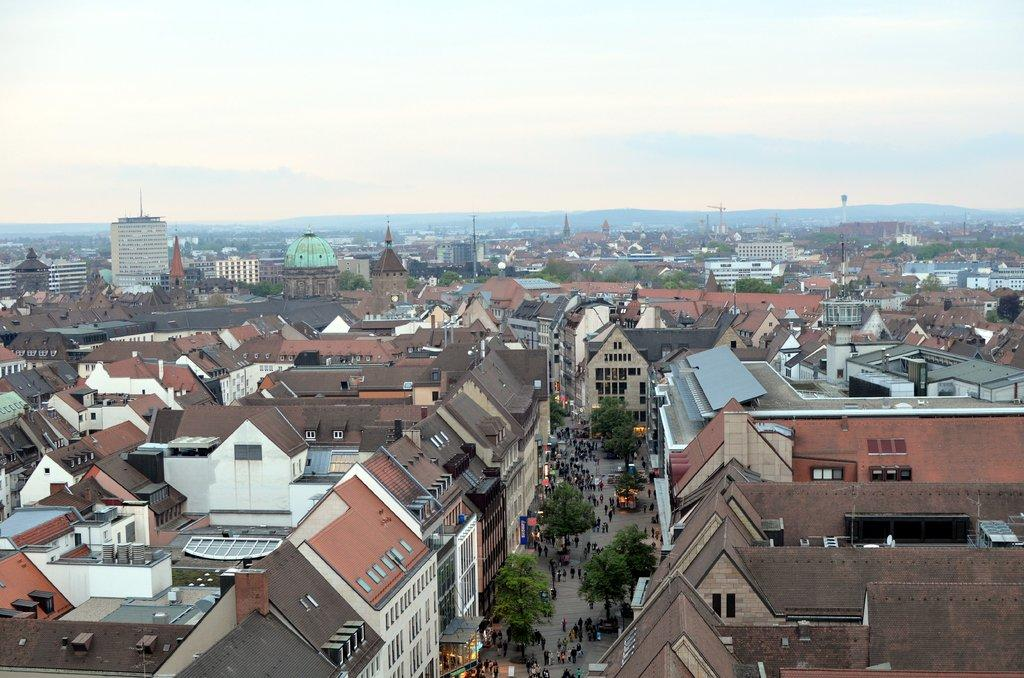What type of structures can be seen in the image? There are buildings and towers in the image. What else is present in the image besides structures? There are trees and people walking in the image. How would you describe the sky in the image? The sky is cloudy in the image. What type of jewel can be seen on the tower in the image? There is no jewel present on the tower in the image. How many mice are visible in the image? There are no mice present in the image. 